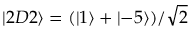<formula> <loc_0><loc_0><loc_500><loc_500>\left | 2 D 2 \right \rangle = ( \left | 1 \right \rangle + \left | - 5 \right \rangle ) / \sqrt { 2 }</formula> 